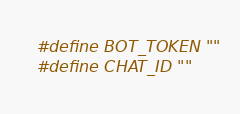<code> <loc_0><loc_0><loc_500><loc_500><_C_>#define BOT_TOKEN ""
#define CHAT_ID ""</code> 